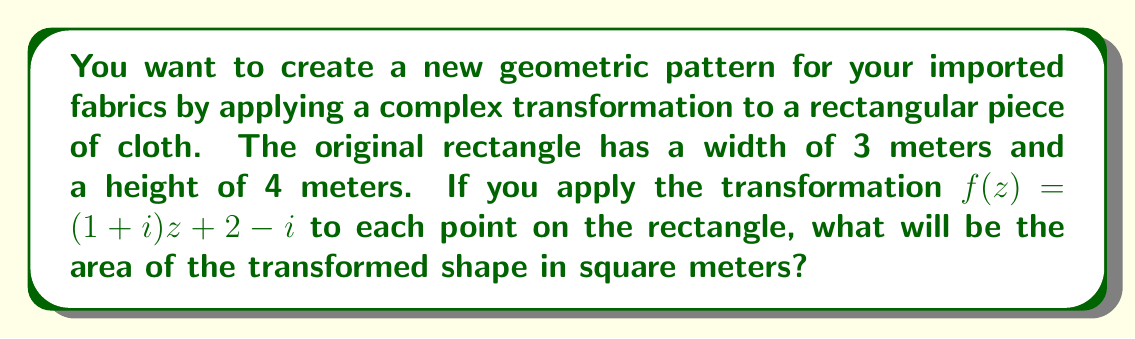Can you answer this question? Let's approach this step-by-step:

1) First, we need to understand what the transformation $f(z) = (1+i)z + 2-i$ does to the complex plane:
   - It scales and rotates the plane (due to multiplication by $1+i$)
   - It then translates the result (due to addition of $2-i$)

2) The scaling factor is given by the modulus of $1+i$:
   $$|(1+i)| = \sqrt{1^2 + 1^2} = \sqrt{2}$$

3) This means that the transformation will scale all distances by a factor of $\sqrt{2}$.

4) The area of a shape is proportional to the square of its linear dimensions. So, if lengths are scaled by $\sqrt{2}$, areas will be scaled by $(\sqrt{2})^2 = 2$.

5) The original rectangle has an area of:
   $$A = 3 \times 4 = 12 \text{ square meters}$$

6) Therefore, the transformed shape will have an area of:
   $$A_{new} = 12 \times 2 = 24 \text{ square meters}$$

Note: The translation part of the transformation $(2-i)$ doesn't affect the area, only the position of the shape in the complex plane.
Answer: 24 square meters 